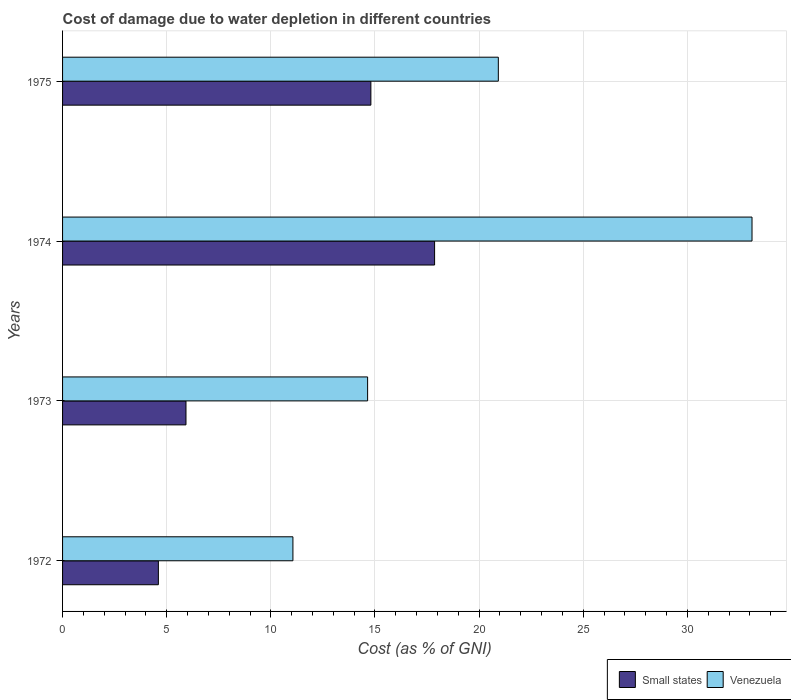How many groups of bars are there?
Ensure brevity in your answer.  4. Are the number of bars on each tick of the Y-axis equal?
Offer a very short reply. Yes. How many bars are there on the 4th tick from the bottom?
Make the answer very short. 2. What is the label of the 3rd group of bars from the top?
Your response must be concise. 1973. What is the cost of damage caused due to water depletion in Venezuela in 1974?
Offer a very short reply. 33.1. Across all years, what is the maximum cost of damage caused due to water depletion in Venezuela?
Offer a very short reply. 33.1. Across all years, what is the minimum cost of damage caused due to water depletion in Small states?
Give a very brief answer. 4.6. In which year was the cost of damage caused due to water depletion in Venezuela maximum?
Provide a succinct answer. 1974. In which year was the cost of damage caused due to water depletion in Small states minimum?
Your answer should be very brief. 1972. What is the total cost of damage caused due to water depletion in Small states in the graph?
Keep it short and to the point. 43.19. What is the difference between the cost of damage caused due to water depletion in Venezuela in 1974 and that in 1975?
Offer a terse response. 12.18. What is the difference between the cost of damage caused due to water depletion in Venezuela in 1972 and the cost of damage caused due to water depletion in Small states in 1974?
Your answer should be very brief. -6.8. What is the average cost of damage caused due to water depletion in Venezuela per year?
Offer a terse response. 19.93. In the year 1975, what is the difference between the cost of damage caused due to water depletion in Venezuela and cost of damage caused due to water depletion in Small states?
Make the answer very short. 6.12. What is the ratio of the cost of damage caused due to water depletion in Venezuela in 1972 to that in 1975?
Keep it short and to the point. 0.53. Is the difference between the cost of damage caused due to water depletion in Venezuela in 1972 and 1974 greater than the difference between the cost of damage caused due to water depletion in Small states in 1972 and 1974?
Your response must be concise. No. What is the difference between the highest and the second highest cost of damage caused due to water depletion in Small states?
Give a very brief answer. 3.06. What is the difference between the highest and the lowest cost of damage caused due to water depletion in Small states?
Your answer should be very brief. 13.26. Is the sum of the cost of damage caused due to water depletion in Venezuela in 1974 and 1975 greater than the maximum cost of damage caused due to water depletion in Small states across all years?
Your response must be concise. Yes. What does the 1st bar from the top in 1973 represents?
Offer a terse response. Venezuela. What does the 2nd bar from the bottom in 1975 represents?
Give a very brief answer. Venezuela. How many bars are there?
Make the answer very short. 8. Are all the bars in the graph horizontal?
Ensure brevity in your answer.  Yes. Does the graph contain grids?
Provide a succinct answer. Yes. How are the legend labels stacked?
Give a very brief answer. Horizontal. What is the title of the graph?
Provide a short and direct response. Cost of damage due to water depletion in different countries. What is the label or title of the X-axis?
Make the answer very short. Cost (as % of GNI). What is the Cost (as % of GNI) in Small states in 1972?
Ensure brevity in your answer.  4.6. What is the Cost (as % of GNI) in Venezuela in 1972?
Offer a very short reply. 11.06. What is the Cost (as % of GNI) in Small states in 1973?
Your response must be concise. 5.93. What is the Cost (as % of GNI) in Venezuela in 1973?
Keep it short and to the point. 14.65. What is the Cost (as % of GNI) in Small states in 1974?
Offer a terse response. 17.86. What is the Cost (as % of GNI) of Venezuela in 1974?
Offer a terse response. 33.1. What is the Cost (as % of GNI) of Small states in 1975?
Provide a short and direct response. 14.8. What is the Cost (as % of GNI) in Venezuela in 1975?
Your answer should be very brief. 20.92. Across all years, what is the maximum Cost (as % of GNI) in Small states?
Provide a succinct answer. 17.86. Across all years, what is the maximum Cost (as % of GNI) in Venezuela?
Keep it short and to the point. 33.1. Across all years, what is the minimum Cost (as % of GNI) of Small states?
Offer a very short reply. 4.6. Across all years, what is the minimum Cost (as % of GNI) in Venezuela?
Your answer should be compact. 11.06. What is the total Cost (as % of GNI) in Small states in the graph?
Give a very brief answer. 43.19. What is the total Cost (as % of GNI) in Venezuela in the graph?
Offer a very short reply. 79.73. What is the difference between the Cost (as % of GNI) of Small states in 1972 and that in 1973?
Make the answer very short. -1.33. What is the difference between the Cost (as % of GNI) of Venezuela in 1972 and that in 1973?
Ensure brevity in your answer.  -3.59. What is the difference between the Cost (as % of GNI) in Small states in 1972 and that in 1974?
Offer a very short reply. -13.26. What is the difference between the Cost (as % of GNI) of Venezuela in 1972 and that in 1974?
Your response must be concise. -22.04. What is the difference between the Cost (as % of GNI) in Small states in 1972 and that in 1975?
Offer a terse response. -10.2. What is the difference between the Cost (as % of GNI) in Venezuela in 1972 and that in 1975?
Make the answer very short. -9.86. What is the difference between the Cost (as % of GNI) of Small states in 1973 and that in 1974?
Offer a very short reply. -11.94. What is the difference between the Cost (as % of GNI) in Venezuela in 1973 and that in 1974?
Your answer should be very brief. -18.46. What is the difference between the Cost (as % of GNI) of Small states in 1973 and that in 1975?
Provide a short and direct response. -8.88. What is the difference between the Cost (as % of GNI) of Venezuela in 1973 and that in 1975?
Make the answer very short. -6.28. What is the difference between the Cost (as % of GNI) in Small states in 1974 and that in 1975?
Your answer should be very brief. 3.06. What is the difference between the Cost (as % of GNI) of Venezuela in 1974 and that in 1975?
Offer a very short reply. 12.18. What is the difference between the Cost (as % of GNI) in Small states in 1972 and the Cost (as % of GNI) in Venezuela in 1973?
Ensure brevity in your answer.  -10.05. What is the difference between the Cost (as % of GNI) of Small states in 1972 and the Cost (as % of GNI) of Venezuela in 1974?
Your answer should be compact. -28.5. What is the difference between the Cost (as % of GNI) in Small states in 1972 and the Cost (as % of GNI) in Venezuela in 1975?
Your response must be concise. -16.32. What is the difference between the Cost (as % of GNI) of Small states in 1973 and the Cost (as % of GNI) of Venezuela in 1974?
Give a very brief answer. -27.18. What is the difference between the Cost (as % of GNI) of Small states in 1973 and the Cost (as % of GNI) of Venezuela in 1975?
Your answer should be very brief. -15. What is the difference between the Cost (as % of GNI) of Small states in 1974 and the Cost (as % of GNI) of Venezuela in 1975?
Your answer should be very brief. -3.06. What is the average Cost (as % of GNI) of Small states per year?
Offer a terse response. 10.8. What is the average Cost (as % of GNI) in Venezuela per year?
Your answer should be very brief. 19.93. In the year 1972, what is the difference between the Cost (as % of GNI) in Small states and Cost (as % of GNI) in Venezuela?
Offer a very short reply. -6.46. In the year 1973, what is the difference between the Cost (as % of GNI) in Small states and Cost (as % of GNI) in Venezuela?
Offer a very short reply. -8.72. In the year 1974, what is the difference between the Cost (as % of GNI) of Small states and Cost (as % of GNI) of Venezuela?
Make the answer very short. -15.24. In the year 1975, what is the difference between the Cost (as % of GNI) of Small states and Cost (as % of GNI) of Venezuela?
Provide a short and direct response. -6.12. What is the ratio of the Cost (as % of GNI) in Small states in 1972 to that in 1973?
Provide a short and direct response. 0.78. What is the ratio of the Cost (as % of GNI) in Venezuela in 1972 to that in 1973?
Your response must be concise. 0.76. What is the ratio of the Cost (as % of GNI) of Small states in 1972 to that in 1974?
Give a very brief answer. 0.26. What is the ratio of the Cost (as % of GNI) of Venezuela in 1972 to that in 1974?
Ensure brevity in your answer.  0.33. What is the ratio of the Cost (as % of GNI) in Small states in 1972 to that in 1975?
Ensure brevity in your answer.  0.31. What is the ratio of the Cost (as % of GNI) of Venezuela in 1972 to that in 1975?
Give a very brief answer. 0.53. What is the ratio of the Cost (as % of GNI) of Small states in 1973 to that in 1974?
Offer a very short reply. 0.33. What is the ratio of the Cost (as % of GNI) in Venezuela in 1973 to that in 1974?
Make the answer very short. 0.44. What is the ratio of the Cost (as % of GNI) in Small states in 1973 to that in 1975?
Your answer should be compact. 0.4. What is the ratio of the Cost (as % of GNI) of Small states in 1974 to that in 1975?
Your answer should be very brief. 1.21. What is the ratio of the Cost (as % of GNI) in Venezuela in 1974 to that in 1975?
Provide a short and direct response. 1.58. What is the difference between the highest and the second highest Cost (as % of GNI) in Small states?
Provide a succinct answer. 3.06. What is the difference between the highest and the second highest Cost (as % of GNI) in Venezuela?
Your answer should be compact. 12.18. What is the difference between the highest and the lowest Cost (as % of GNI) in Small states?
Your answer should be very brief. 13.26. What is the difference between the highest and the lowest Cost (as % of GNI) of Venezuela?
Offer a very short reply. 22.04. 